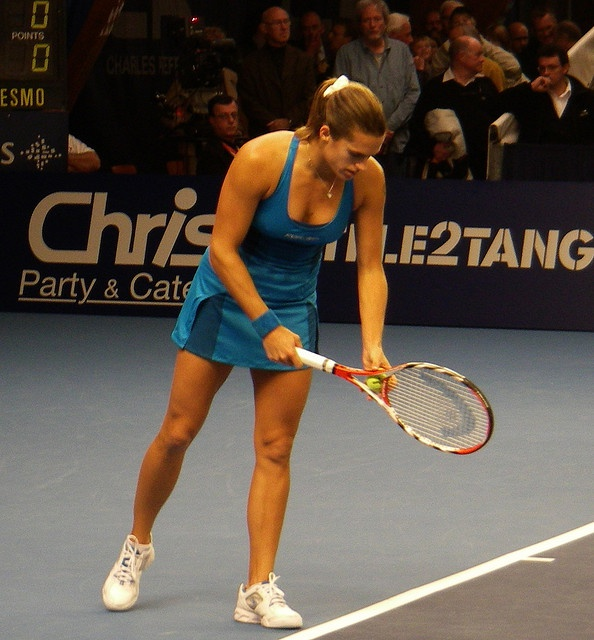Describe the objects in this image and their specific colors. I can see people in black, brown, maroon, and orange tones, people in black, maroon, and gray tones, tennis racket in black, darkgray, gray, and tan tones, people in black, maroon, and brown tones, and people in black, maroon, and gray tones in this image. 